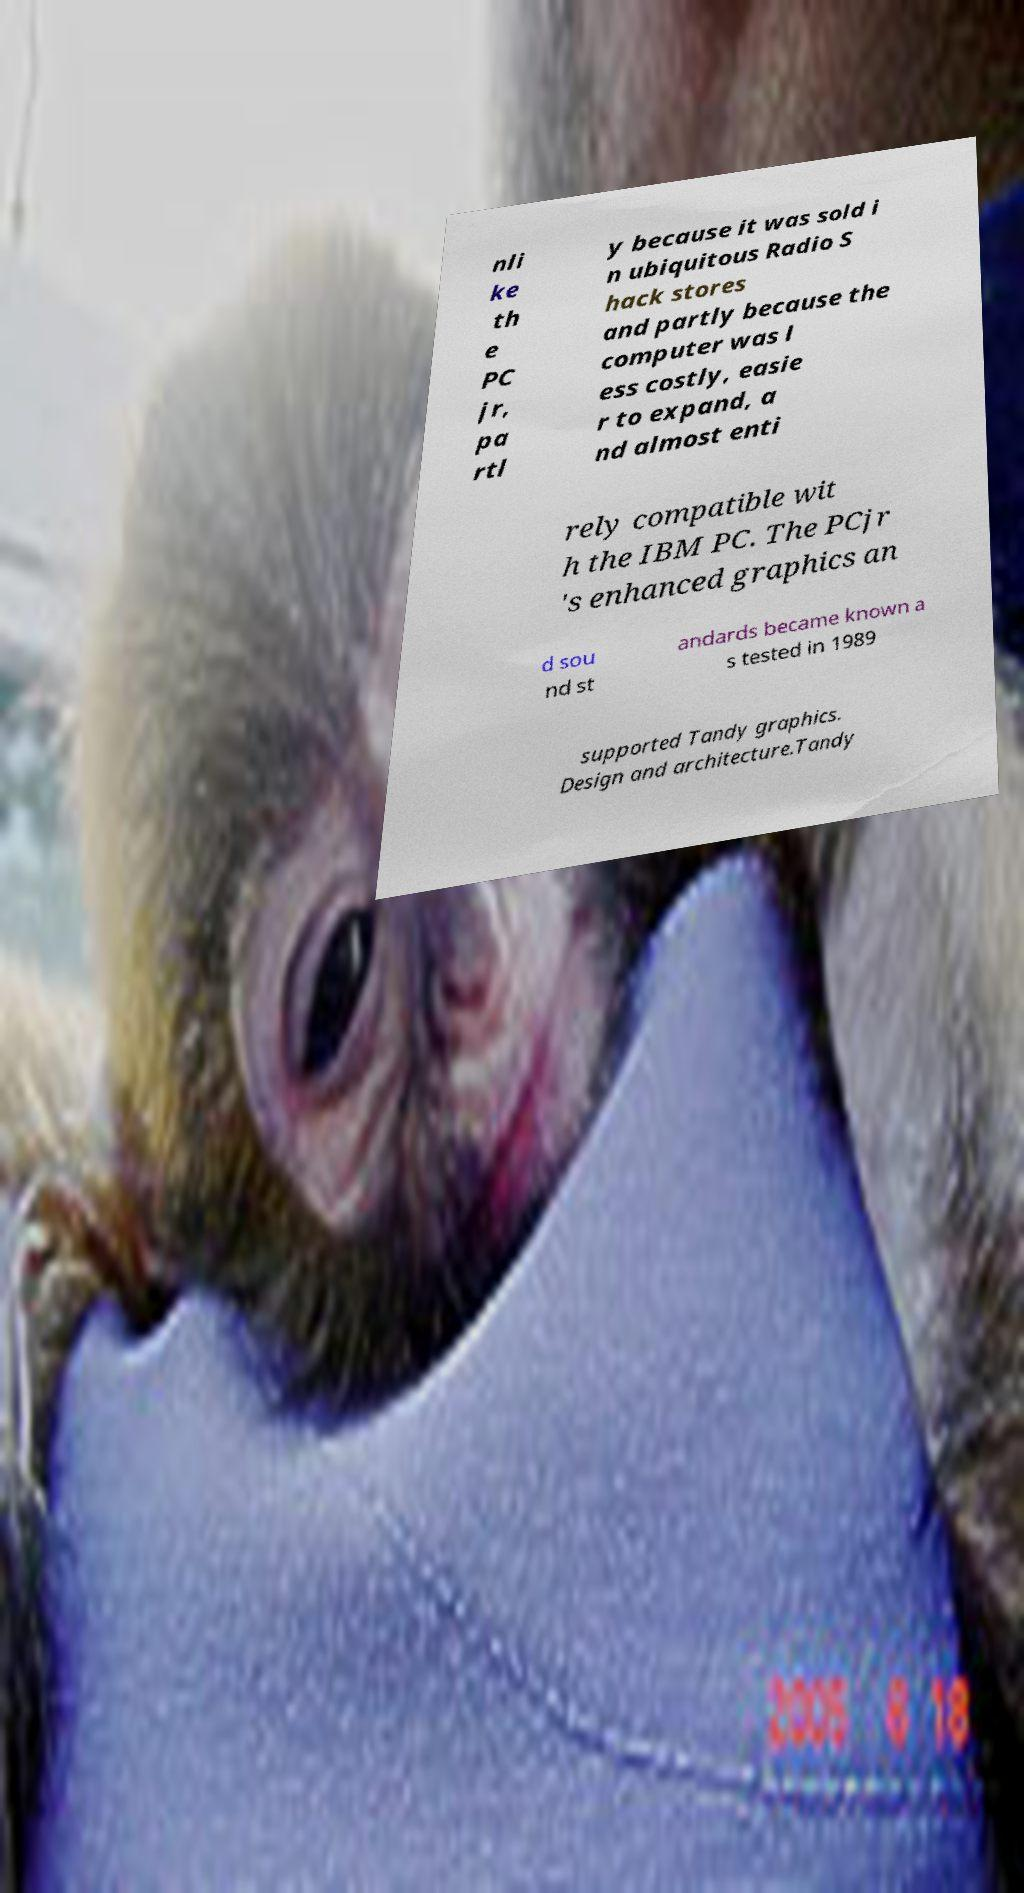Can you accurately transcribe the text from the provided image for me? nli ke th e PC jr, pa rtl y because it was sold i n ubiquitous Radio S hack stores and partly because the computer was l ess costly, easie r to expand, a nd almost enti rely compatible wit h the IBM PC. The PCjr 's enhanced graphics an d sou nd st andards became known a s tested in 1989 supported Tandy graphics. Design and architecture.Tandy 